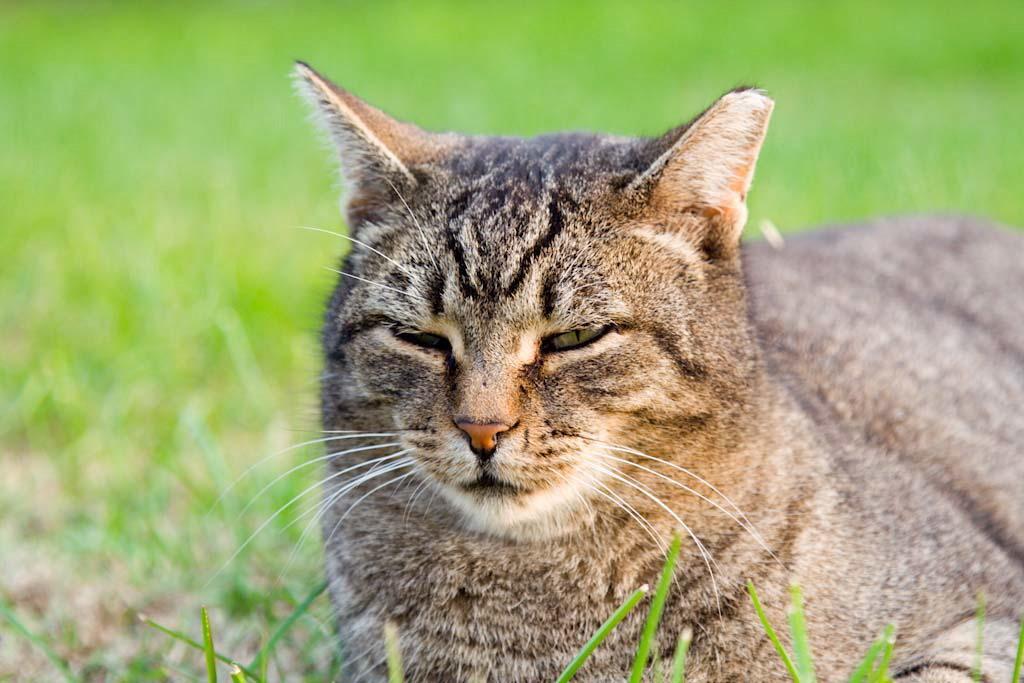In one or two sentences, can you explain what this image depicts? In this image, we can see a cat on the blur background. 